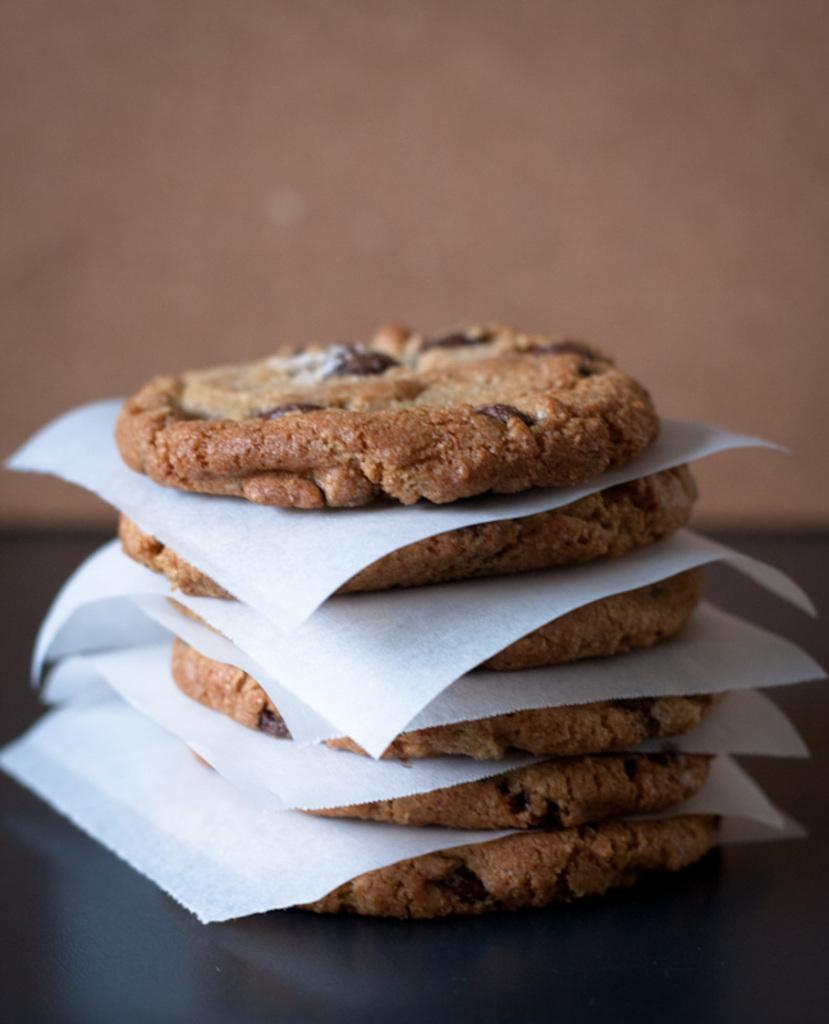What is on the black surface in the image? There are cookies and papers on the black surface. Can you describe the background of the image? There is a wall visible in the background of the image. How many tomatoes are on the trousers in the image? There are no tomatoes or trousers present in the image. Is there a person visible in the image? There is no person visible in the image; only cookies, papers, and a wall are present. 